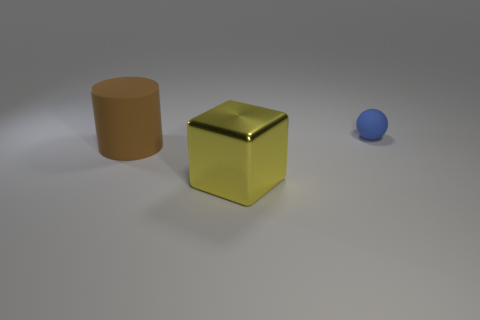Is the color of the large shiny object the same as the tiny matte ball?
Offer a terse response. No. How many tiny objects are shiny things or cyan metal spheres?
Offer a very short reply. 0. Is there anything else that is the same color as the big block?
Make the answer very short. No. There is a blue object that is made of the same material as the large brown cylinder; what shape is it?
Offer a terse response. Sphere. There is a rubber object that is behind the big brown matte cylinder; how big is it?
Keep it short and to the point. Small. What is the shape of the blue object?
Your answer should be very brief. Sphere. There is a rubber object that is right of the large brown matte cylinder; does it have the same size as the object that is in front of the big brown matte thing?
Offer a terse response. No. There is a thing that is on the left side of the big object that is in front of the rubber object in front of the small blue rubber ball; how big is it?
Ensure brevity in your answer.  Large. There is a rubber object that is to the left of the small blue rubber ball that is behind the matte thing that is to the left of the tiny blue rubber thing; what is its shape?
Offer a terse response. Cylinder. There is a thing behind the brown rubber cylinder; what is its shape?
Make the answer very short. Sphere. 